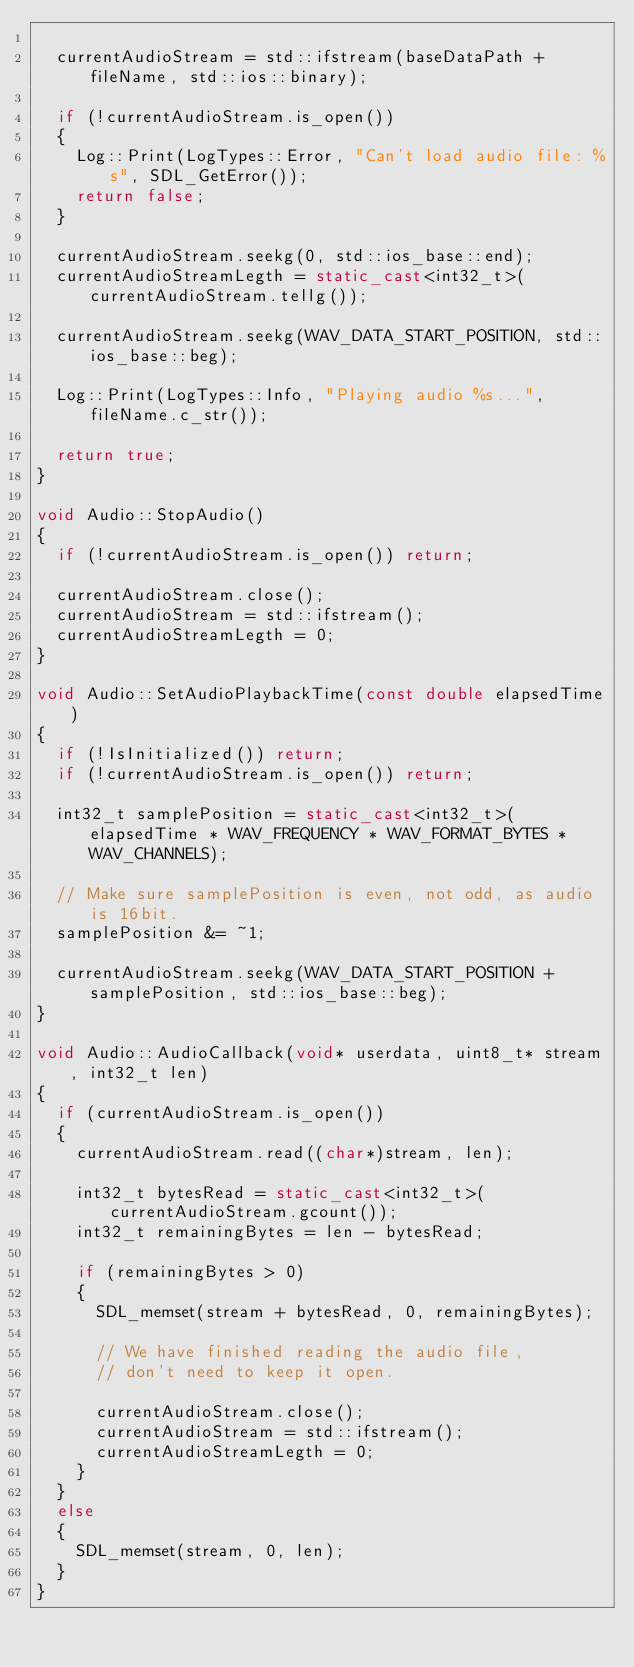<code> <loc_0><loc_0><loc_500><loc_500><_C++_>
	currentAudioStream = std::ifstream(baseDataPath + fileName, std::ios::binary);

	if (!currentAudioStream.is_open())
	{
		Log::Print(LogTypes::Error, "Can't load audio file: %s", SDL_GetError());
		return false;
	}

	currentAudioStream.seekg(0, std::ios_base::end);
	currentAudioStreamLegth = static_cast<int32_t>(currentAudioStream.tellg());

	currentAudioStream.seekg(WAV_DATA_START_POSITION, std::ios_base::beg);

	Log::Print(LogTypes::Info, "Playing audio %s...", fileName.c_str());

	return true;
}

void Audio::StopAudio()
{
	if (!currentAudioStream.is_open()) return;

	currentAudioStream.close();
	currentAudioStream = std::ifstream();
	currentAudioStreamLegth = 0;
}

void Audio::SetAudioPlaybackTime(const double elapsedTime)
{
	if (!IsInitialized()) return;
	if (!currentAudioStream.is_open()) return;

	int32_t samplePosition = static_cast<int32_t>(elapsedTime * WAV_FREQUENCY * WAV_FORMAT_BYTES * WAV_CHANNELS);

	// Make sure samplePosition is even, not odd, as audio is 16bit.
	samplePosition &= ~1;

	currentAudioStream.seekg(WAV_DATA_START_POSITION + samplePosition, std::ios_base::beg);
}

void Audio::AudioCallback(void* userdata, uint8_t* stream, int32_t len)
{
	if (currentAudioStream.is_open())
	{
		currentAudioStream.read((char*)stream, len);

		int32_t bytesRead = static_cast<int32_t>(currentAudioStream.gcount());
		int32_t remainingBytes = len - bytesRead;

		if (remainingBytes > 0)
		{
			SDL_memset(stream + bytesRead, 0, remainingBytes);

			// We have finished reading the audio file,
			// don't need to keep it open.

			currentAudioStream.close();
			currentAudioStream = std::ifstream();
			currentAudioStreamLegth = 0;
		}
	}
	else
	{
		SDL_memset(stream, 0, len);
	}
}
</code> 